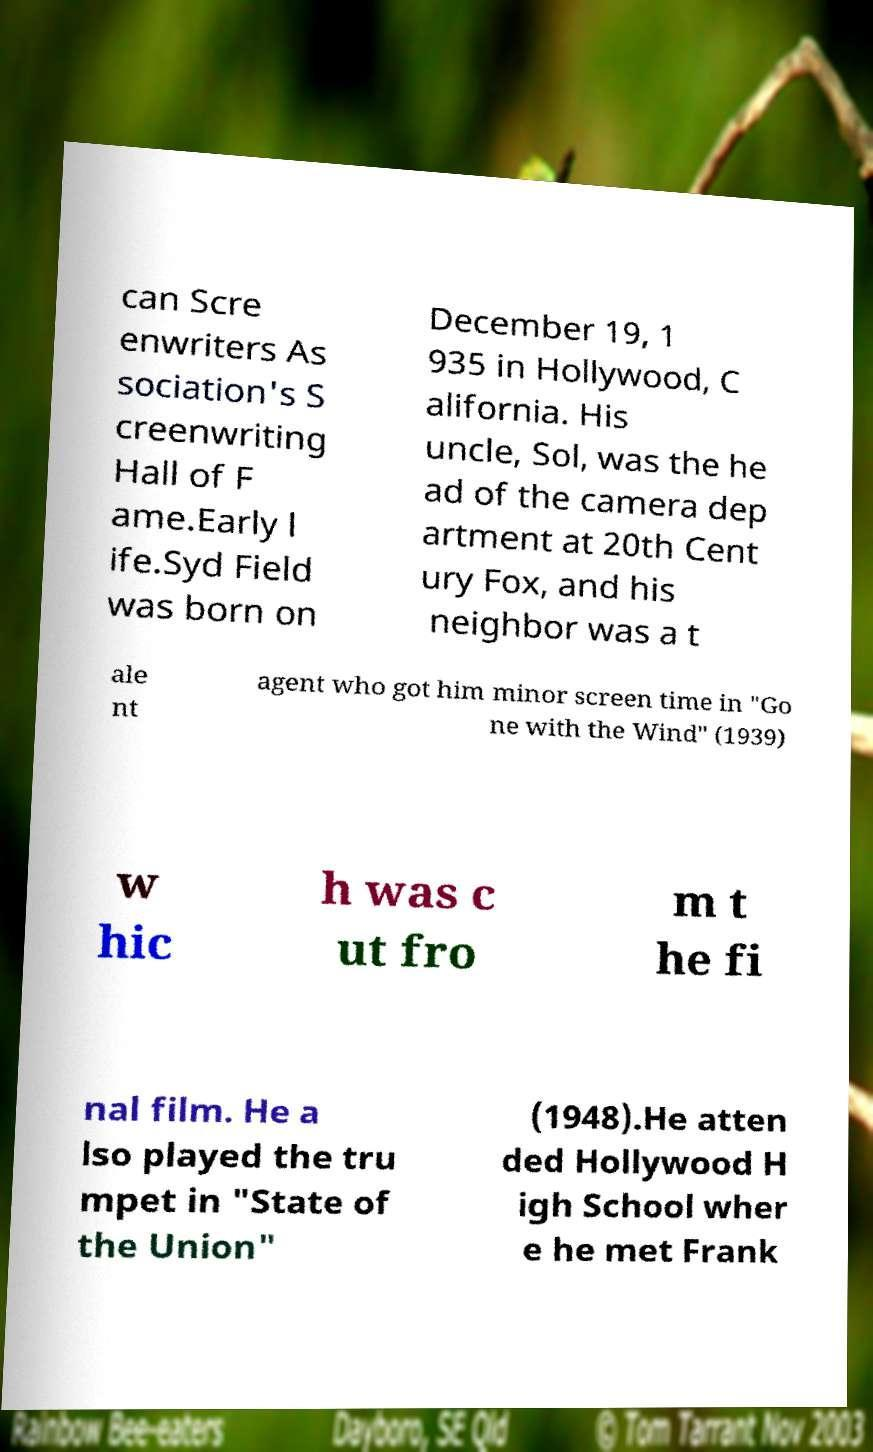For documentation purposes, I need the text within this image transcribed. Could you provide that? can Scre enwriters As sociation's S creenwriting Hall of F ame.Early l ife.Syd Field was born on December 19, 1 935 in Hollywood, C alifornia. His uncle, Sol, was the he ad of the camera dep artment at 20th Cent ury Fox, and his neighbor was a t ale nt agent who got him minor screen time in "Go ne with the Wind" (1939) w hic h was c ut fro m t he fi nal film. He a lso played the tru mpet in "State of the Union" (1948).He atten ded Hollywood H igh School wher e he met Frank 